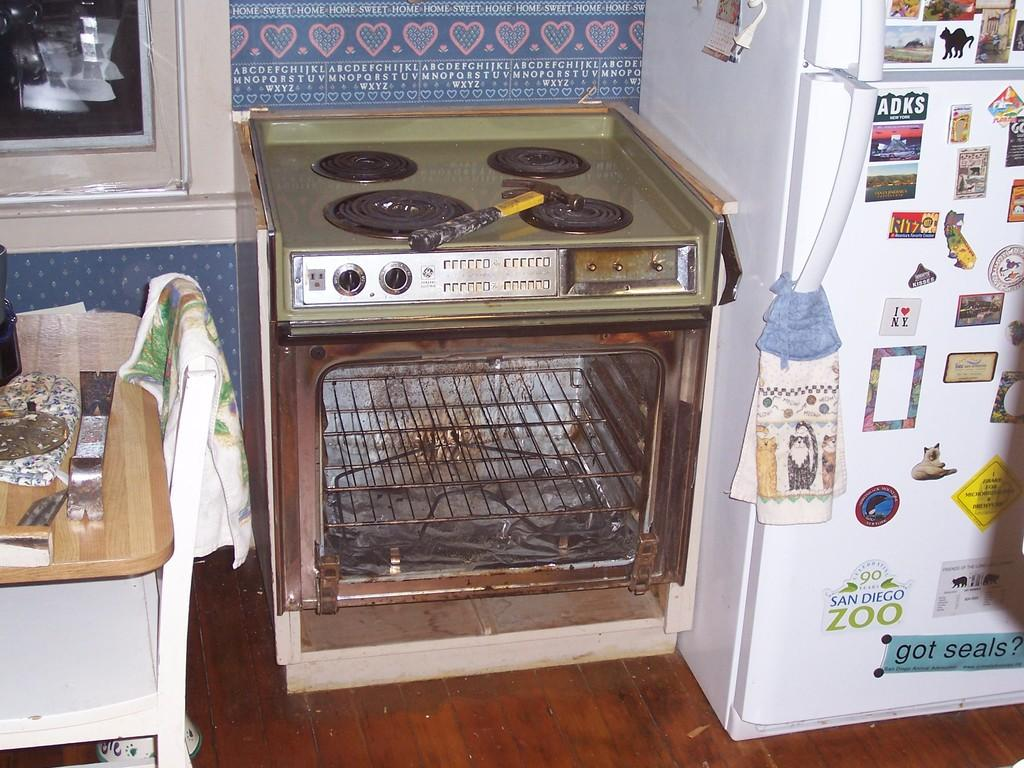<image>
Give a short and clear explanation of the subsequent image. A sticker with ADKS is on the white refrigerator next to the handle. 